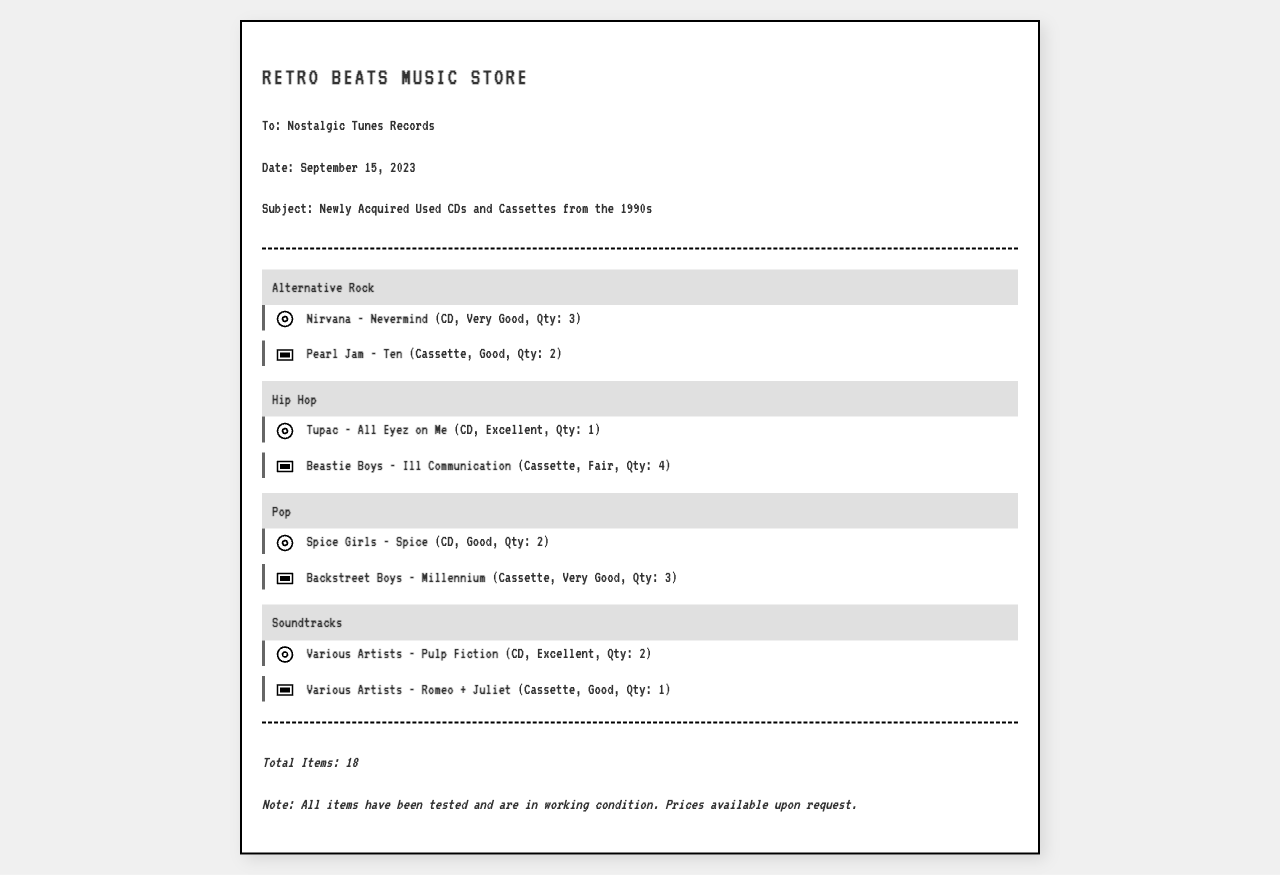What is the date of the fax? The date is specified in the document as September 15, 2023.
Answer: September 15, 2023 How many copies of "Nirvana - Nevermind" are available? The document states there are 3 copies of this CD available.
Answer: 3 What is the condition of "Tupac - All Eyez on Me"? The document indicates that the condition is Excellent.
Answer: Excellent Which genre has the most items listed? By counting the items, we can see that Hip Hop has 5 items listed.
Answer: Hip Hop How many soundtracks are included in the inventory? The document shows that there are 2 CDs and 1 cassette under the Soundtracks genre, totaling 3 items.
Answer: 3 What is the total number of items listed in the inventory? The footer of the document notes that there are a total of 18 items.
Answer: 18 What type of document is this? The document is a faxed inventory list for newly acquired music items.
Answer: Faxed inventory list What is the condition of "Various Artists - Romeo + Juliet" cassette? The condition for this cassette listed in the document is Good.
Answer: Good 